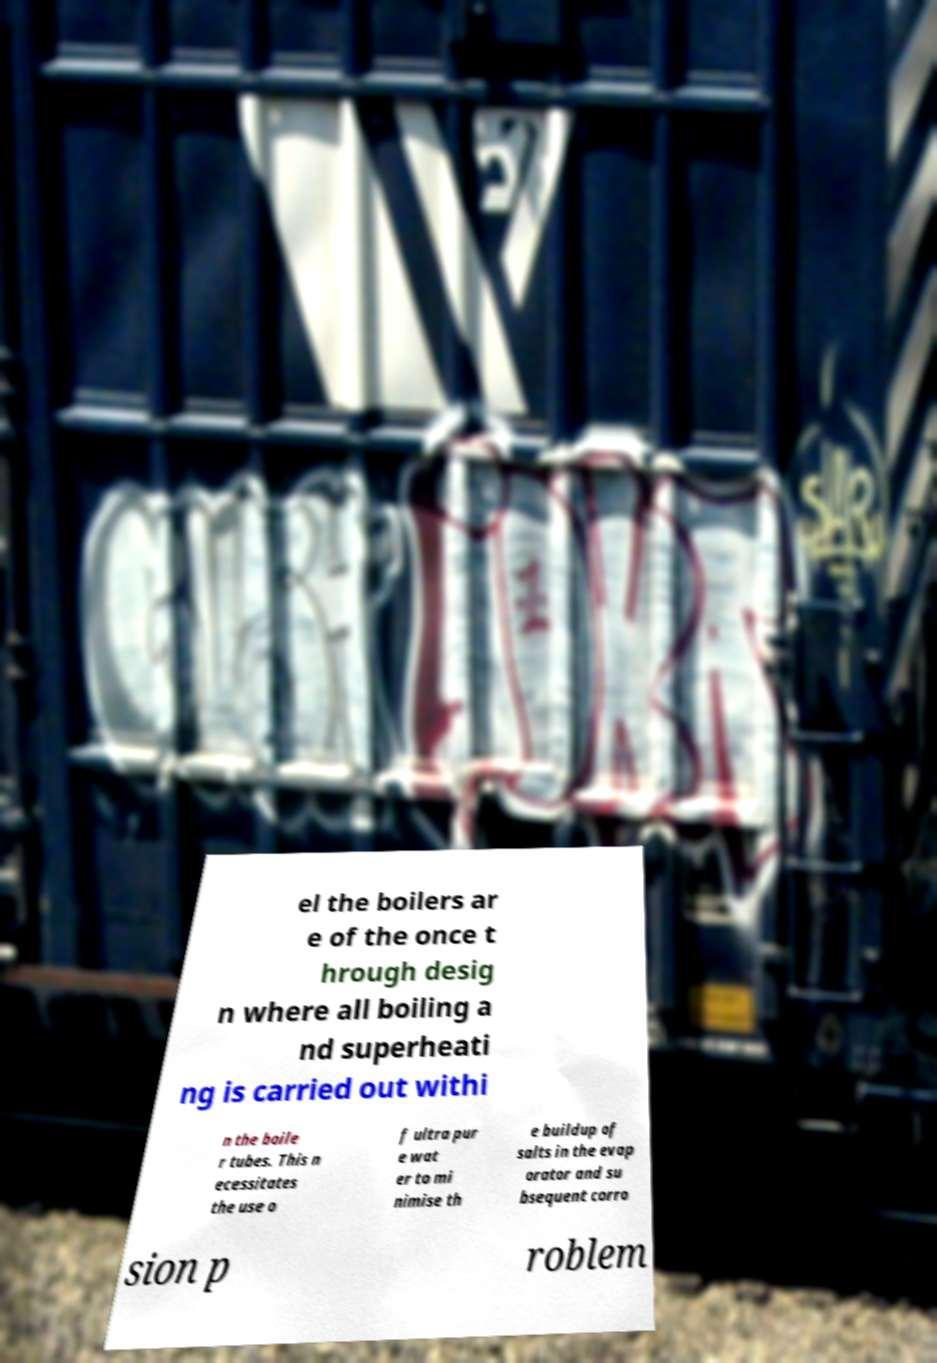For documentation purposes, I need the text within this image transcribed. Could you provide that? el the boilers ar e of the once t hrough desig n where all boiling a nd superheati ng is carried out withi n the boile r tubes. This n ecessitates the use o f ultra pur e wat er to mi nimise th e buildup of salts in the evap orator and su bsequent corro sion p roblem 